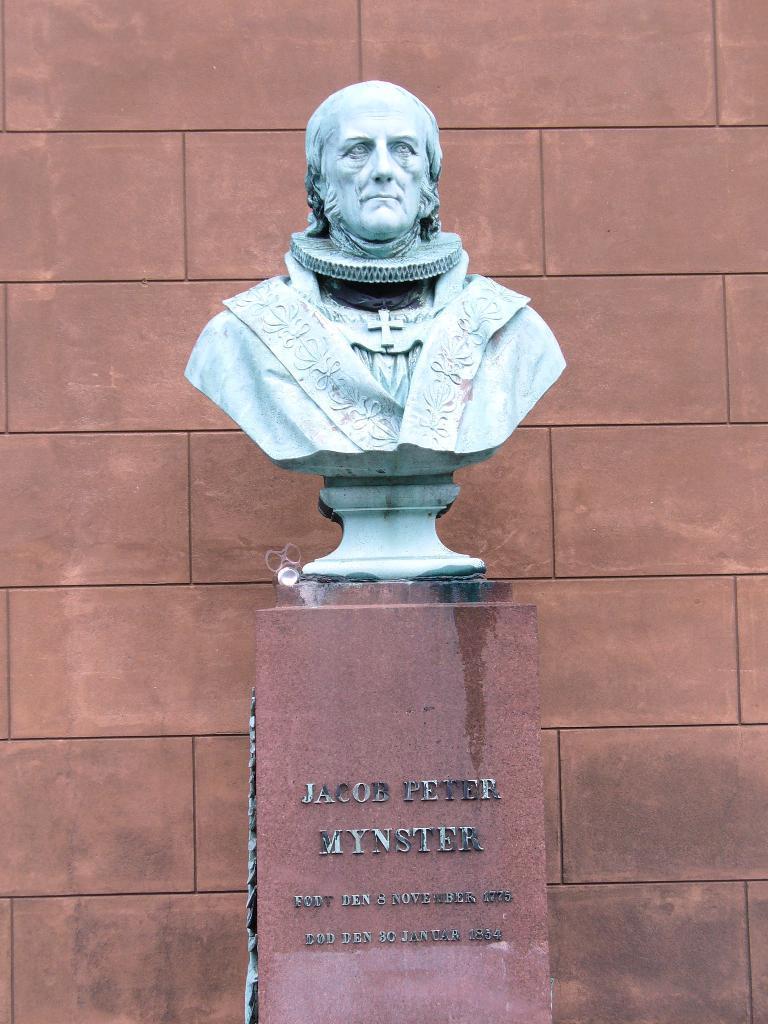Please provide a concise description of this image. In this image there is a statue on the rock structure with some text on it. In the background there is a wall. 